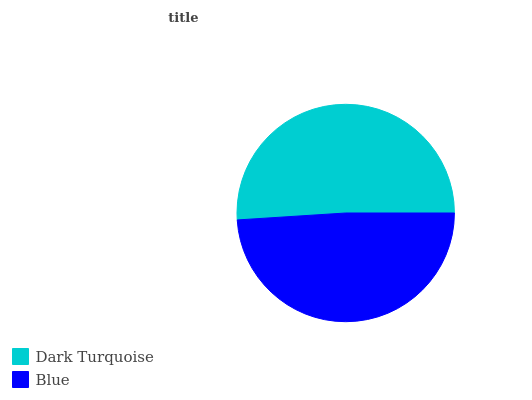Is Blue the minimum?
Answer yes or no. Yes. Is Dark Turquoise the maximum?
Answer yes or no. Yes. Is Blue the maximum?
Answer yes or no. No. Is Dark Turquoise greater than Blue?
Answer yes or no. Yes. Is Blue less than Dark Turquoise?
Answer yes or no. Yes. Is Blue greater than Dark Turquoise?
Answer yes or no. No. Is Dark Turquoise less than Blue?
Answer yes or no. No. Is Dark Turquoise the high median?
Answer yes or no. Yes. Is Blue the low median?
Answer yes or no. Yes. Is Blue the high median?
Answer yes or no. No. Is Dark Turquoise the low median?
Answer yes or no. No. 